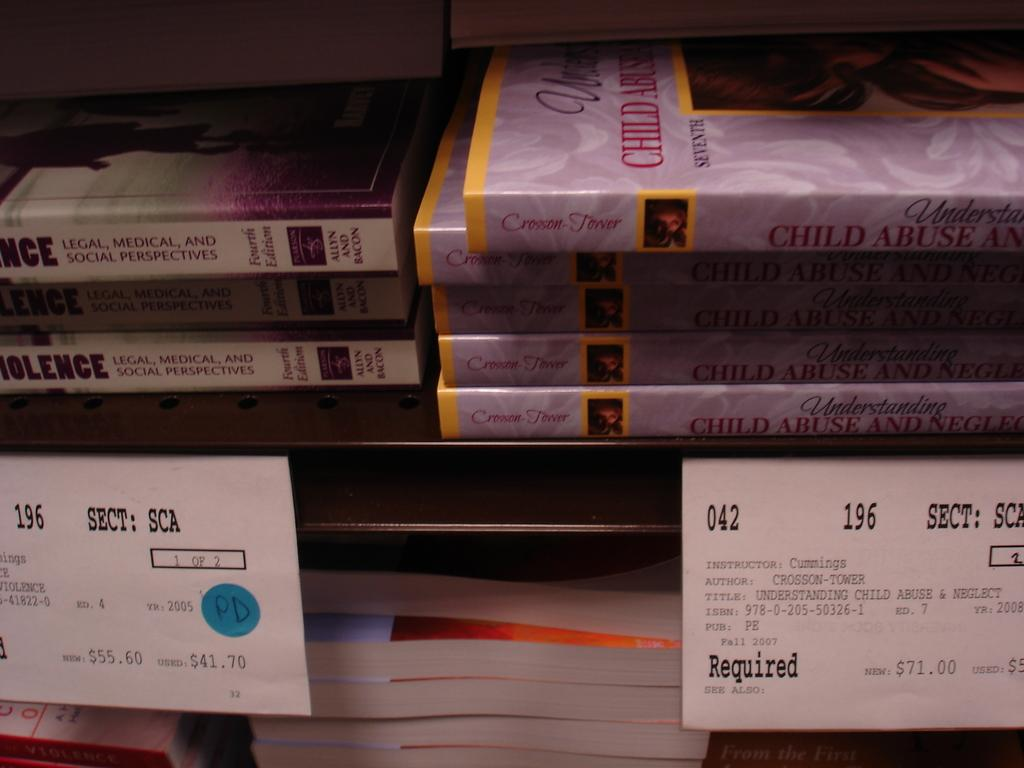<image>
Offer a succinct explanation of the picture presented. Several books, including one on child abuse, are on the shelf at a bookstore. 